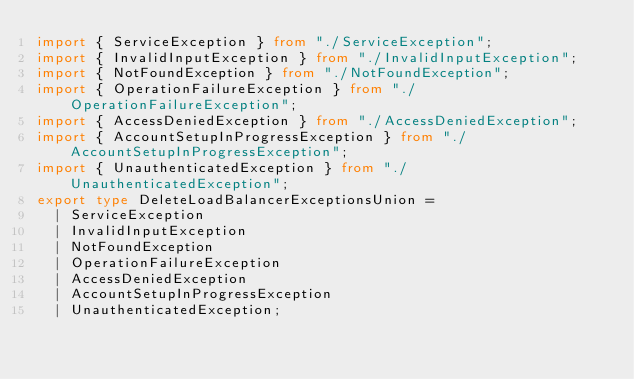<code> <loc_0><loc_0><loc_500><loc_500><_TypeScript_>import { ServiceException } from "./ServiceException";
import { InvalidInputException } from "./InvalidInputException";
import { NotFoundException } from "./NotFoundException";
import { OperationFailureException } from "./OperationFailureException";
import { AccessDeniedException } from "./AccessDeniedException";
import { AccountSetupInProgressException } from "./AccountSetupInProgressException";
import { UnauthenticatedException } from "./UnauthenticatedException";
export type DeleteLoadBalancerExceptionsUnion =
  | ServiceException
  | InvalidInputException
  | NotFoundException
  | OperationFailureException
  | AccessDeniedException
  | AccountSetupInProgressException
  | UnauthenticatedException;
</code> 